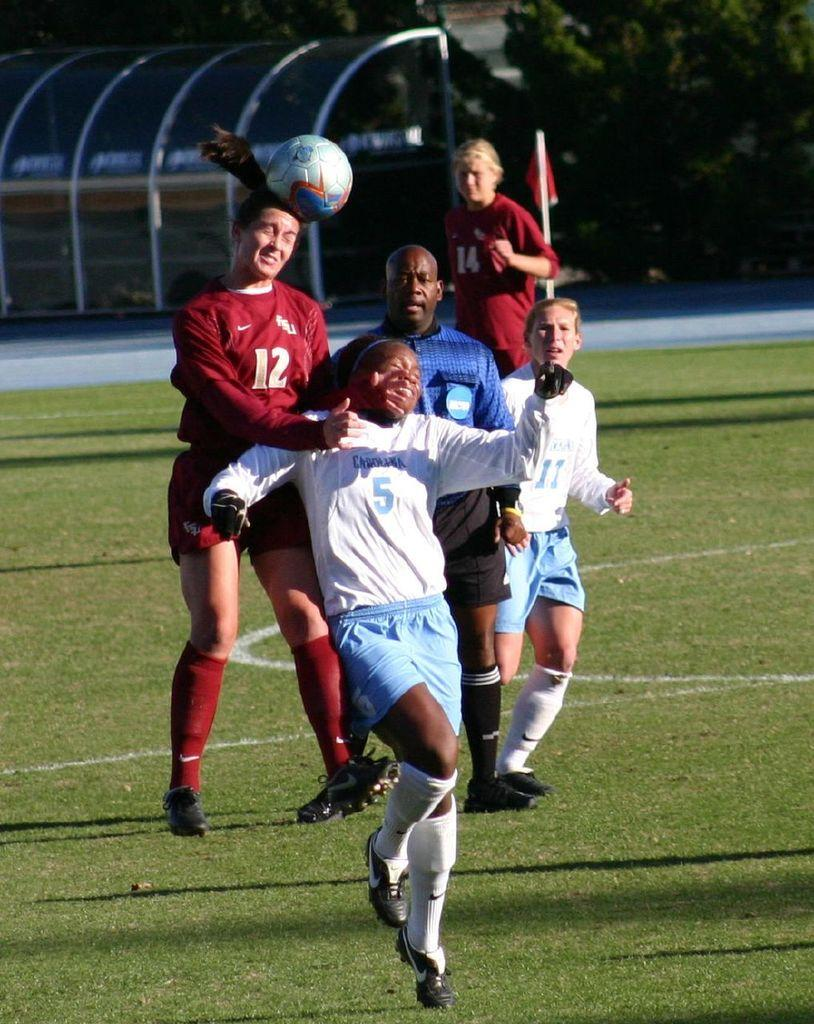What activity are the people in the image engaged in? The people in the image are playing football. What can be seen in the background of the image? There are trees in the background of the image. What is the ground covered with in the image? The ground is covered with greenery. What letters are visible on the football in the image? There are no letters visible on the football in the image. What type of pet can be seen playing with the people in the image? There are no pets present in the image; it only features people playing football. 